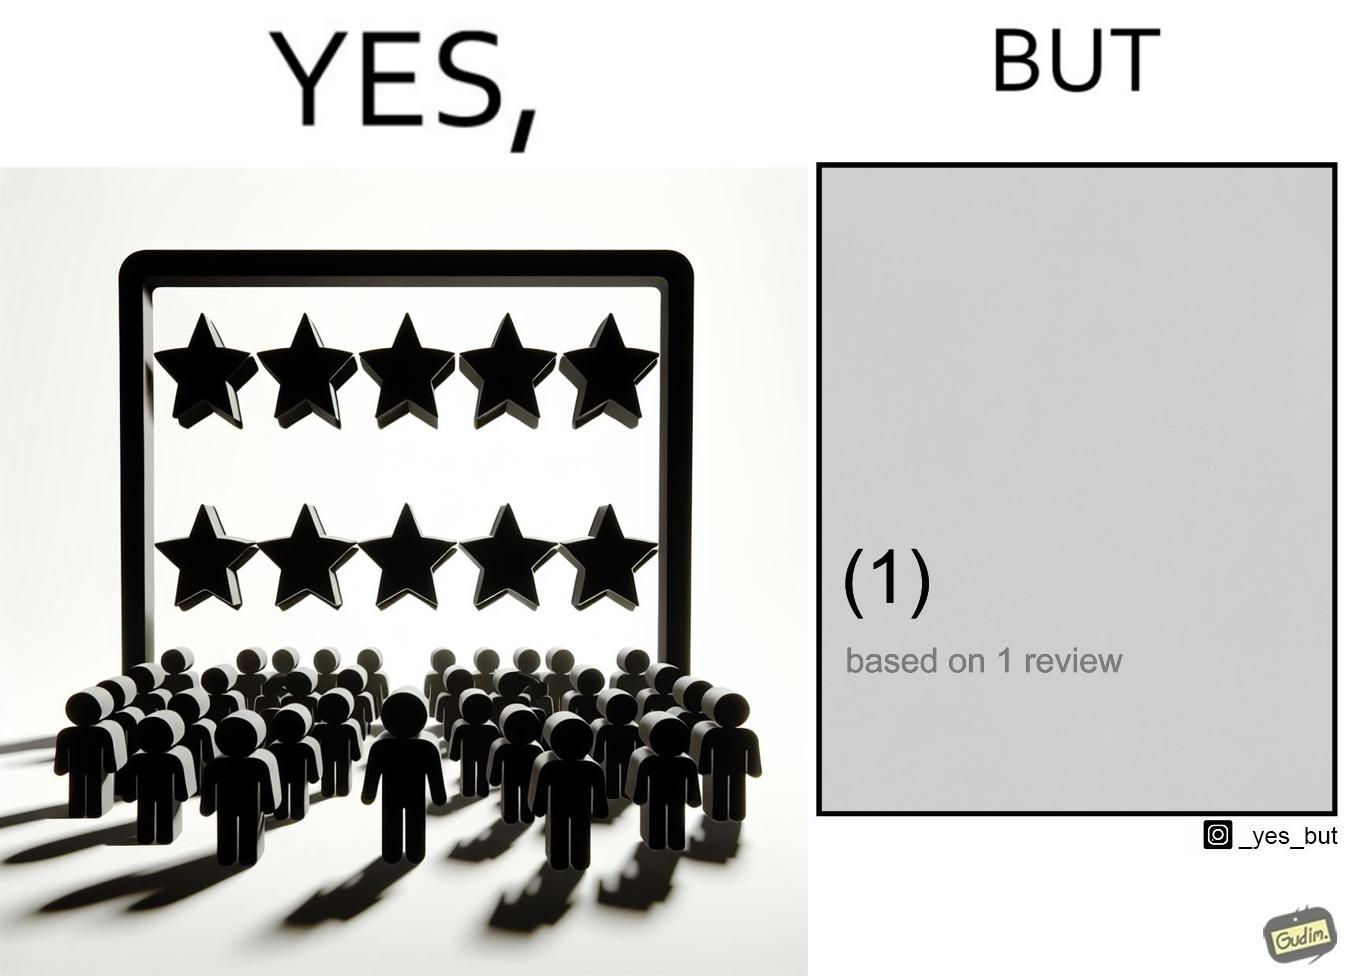Why is this image considered satirical? The image is ironical, as a product/service is rated 5 out of 5 stars, but it has only 1 review, and hence, this rating might actually be misleading. 